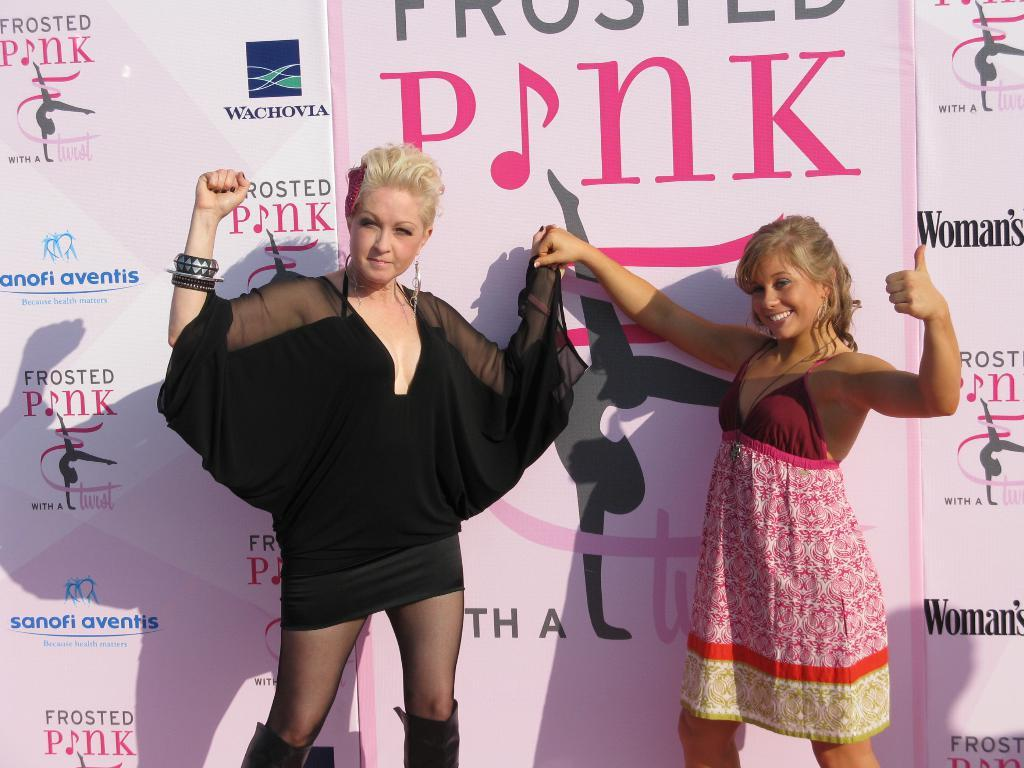How many people are in the image? There are two persons in the image. What can be seen behind the persons? There are banners visible behind the persons. What is written on the banners? The banners have text on them. What symbols are present on the banners? The banners have logos on them. What type of music can be heard coming from the sack in the image? There is no sack present in the image, and therefore no music can be heard coming from it. 